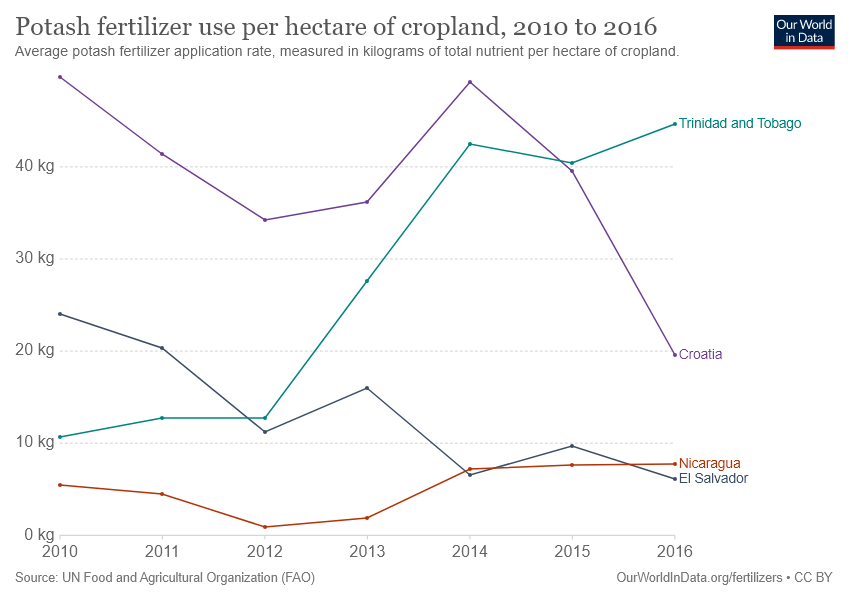Indicate a few pertinent items in this graphic. In 2010, Croatia recorded the highest use of Potash fertilizer. During the period of 2010 to 2016, there were two countries that used more than 40 kilograms of potash fertilizer. 